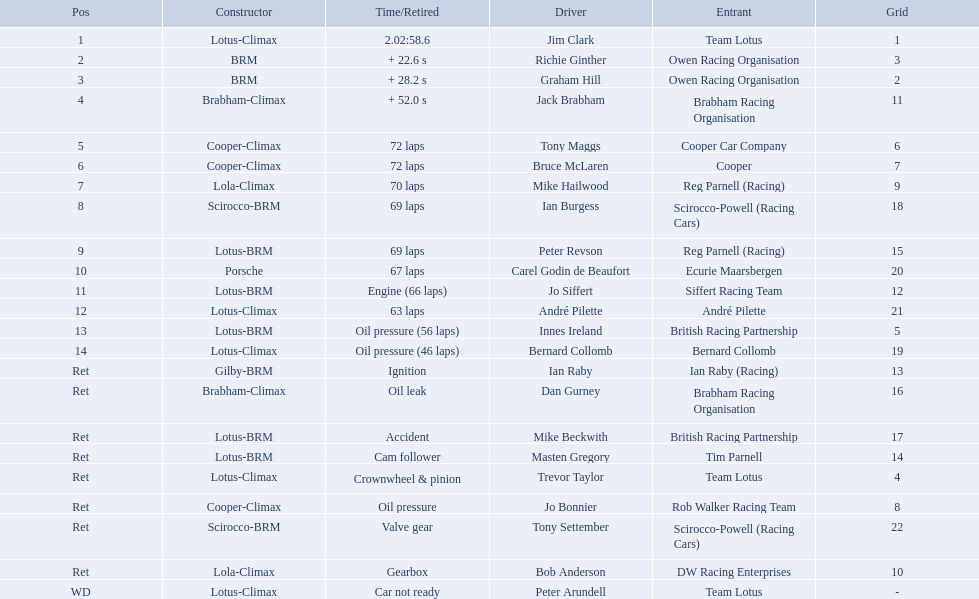Who are all the drivers? Jim Clark, Richie Ginther, Graham Hill, Jack Brabham, Tony Maggs, Bruce McLaren, Mike Hailwood, Ian Burgess, Peter Revson, Carel Godin de Beaufort, Jo Siffert, André Pilette, Innes Ireland, Bernard Collomb, Ian Raby, Dan Gurney, Mike Beckwith, Masten Gregory, Trevor Taylor, Jo Bonnier, Tony Settember, Bob Anderson, Peter Arundell. What were their positions? 1, 2, 3, 4, 5, 6, 7, 8, 9, 10, 11, 12, 13, 14, Ret, Ret, Ret, Ret, Ret, Ret, Ret, Ret, WD. What are all the constructor names? Lotus-Climax, BRM, BRM, Brabham-Climax, Cooper-Climax, Cooper-Climax, Lola-Climax, Scirocco-BRM, Lotus-BRM, Porsche, Lotus-BRM, Lotus-Climax, Lotus-BRM, Lotus-Climax, Gilby-BRM, Brabham-Climax, Lotus-BRM, Lotus-BRM, Lotus-Climax, Cooper-Climax, Scirocco-BRM, Lola-Climax, Lotus-Climax. And which drivers drove a cooper-climax? Tony Maggs, Bruce McLaren. Between those tow, who was positioned higher? Tony Maggs. 